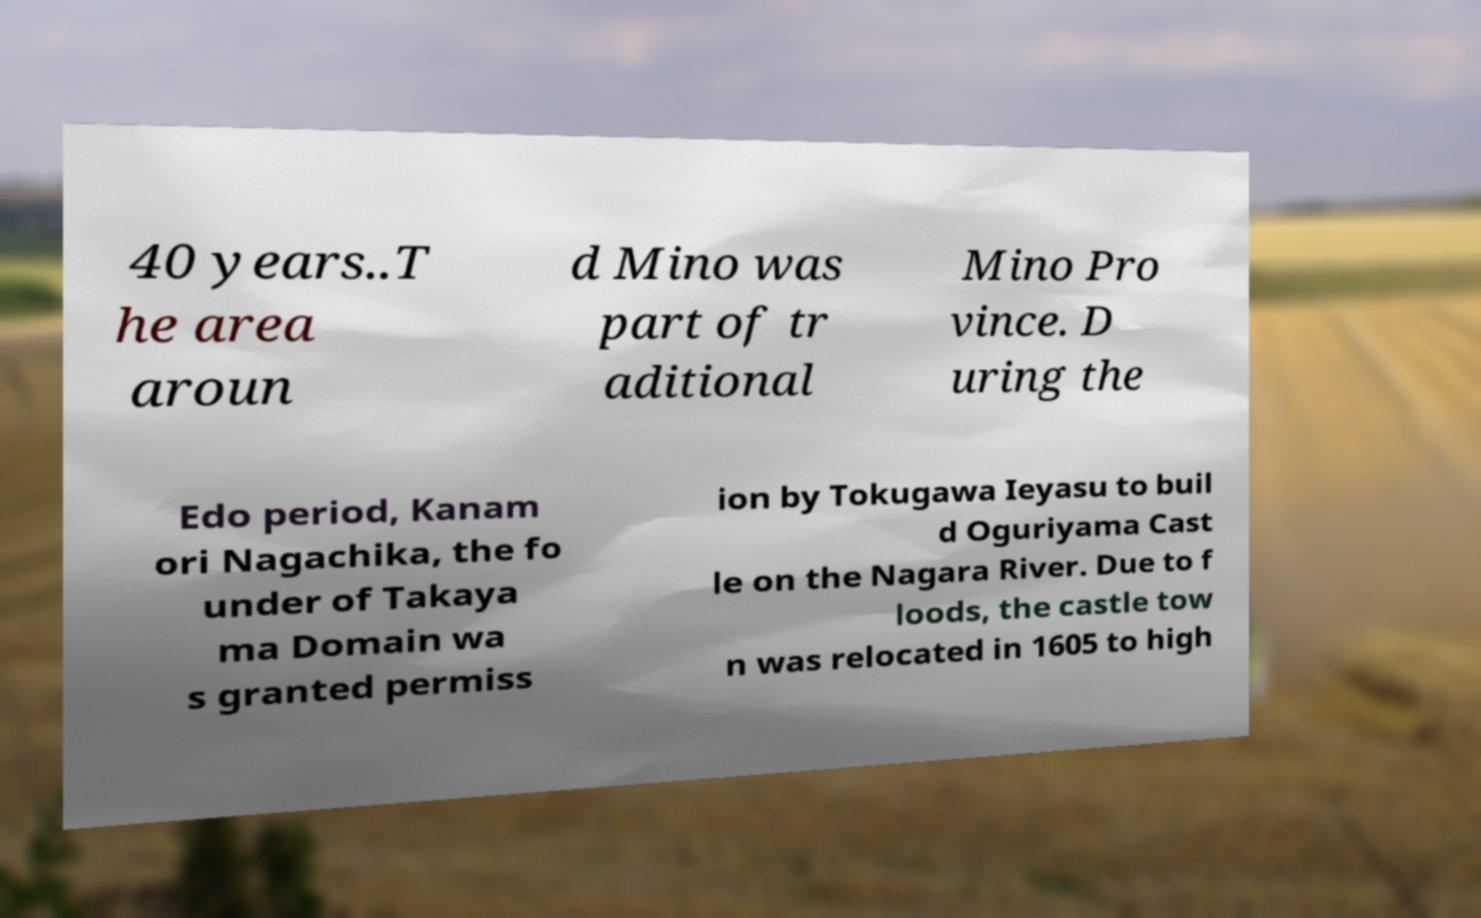For documentation purposes, I need the text within this image transcribed. Could you provide that? 40 years..T he area aroun d Mino was part of tr aditional Mino Pro vince. D uring the Edo period, Kanam ori Nagachika, the fo under of Takaya ma Domain wa s granted permiss ion by Tokugawa Ieyasu to buil d Oguriyama Cast le on the Nagara River. Due to f loods, the castle tow n was relocated in 1605 to high 